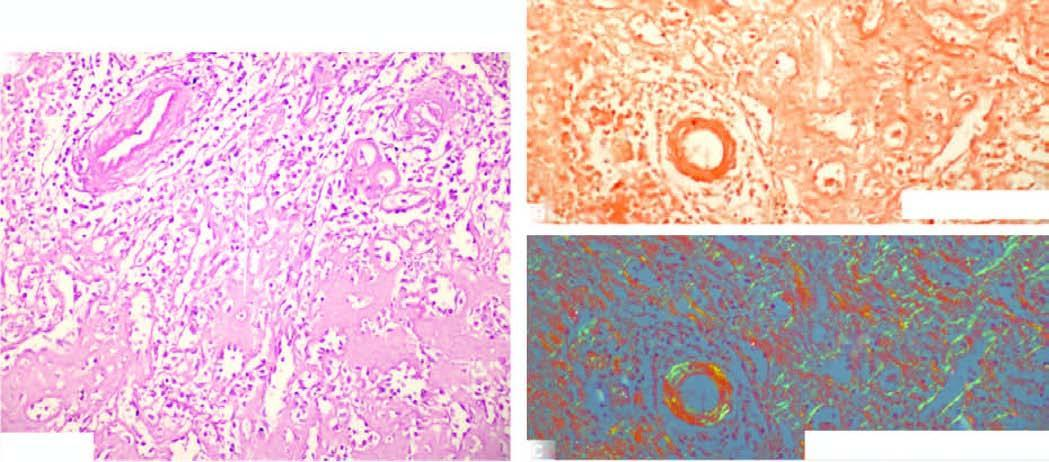s the pink acellular amyloid material seen in the red pulp causing atrophy of while pulp?
Answer the question using a single word or phrase. Yes 